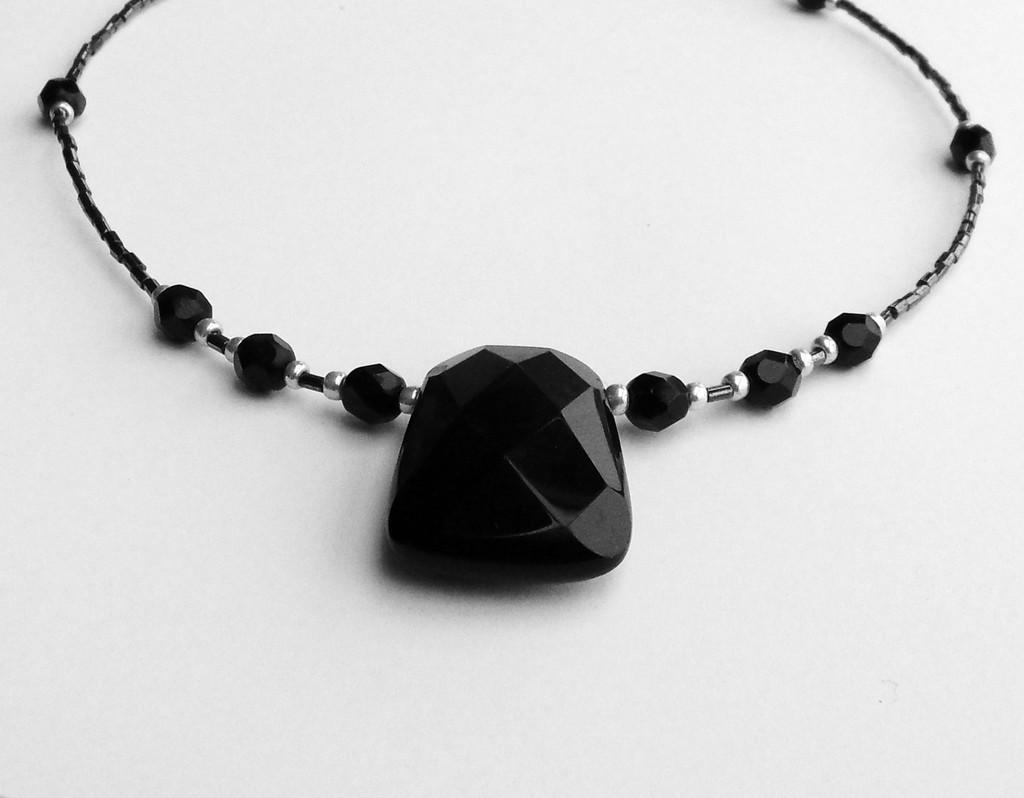What type of jewelry is present in the image? There is a necklace in the image. What is the color of the necklace? The necklace is black in color. What type of stones are on the necklace? The necklace has black stones. Where is the necklace placed in the image? The necklace is placed on a table or desk. What is the color of the table or desk? The table or desk is white in color. Can you see a bat flying around the necklace in the image? There is no bat present in the image. Is there a knife lying on the white table or desk in the image? There is no knife mentioned or visible in the image. 